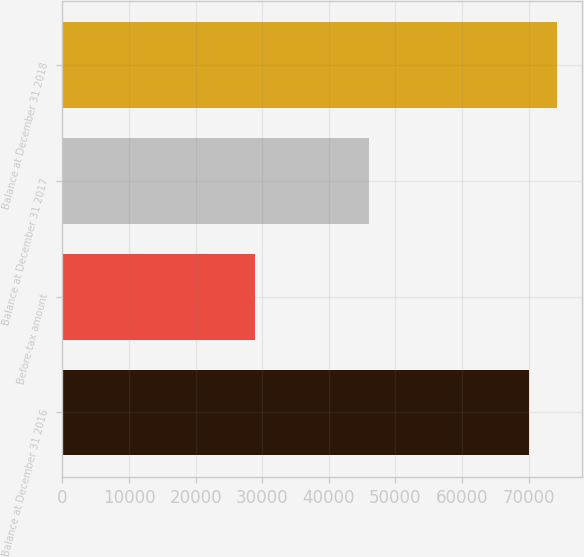Convert chart to OTSL. <chart><loc_0><loc_0><loc_500><loc_500><bar_chart><fcel>Balance at December 31 2016<fcel>Before-tax amount<fcel>Balance at December 31 2017<fcel>Balance at December 31 2018<nl><fcel>70075<fcel>28940<fcel>45956<fcel>74288.8<nl></chart> 